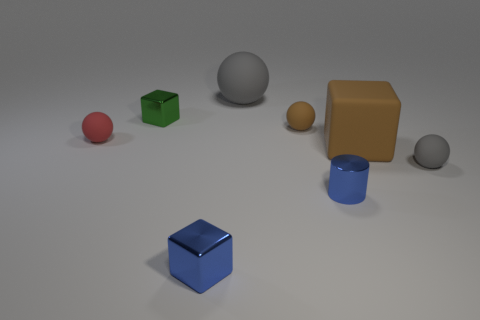There is a small thing that is the same color as the small shiny cylinder; what shape is it?
Make the answer very short. Cube. How many tiny metallic blocks are the same color as the tiny cylinder?
Your answer should be very brief. 1. Do the small sphere that is behind the tiny red matte sphere and the matte block have the same color?
Your response must be concise. Yes. What number of gray things are made of the same material as the large brown object?
Provide a short and direct response. 2. There is a gray ball behind the metallic block behind the ball to the left of the small green thing; what size is it?
Make the answer very short. Large. There is a small red thing; how many small green metal cubes are right of it?
Make the answer very short. 1. Is the number of large gray objects greater than the number of matte spheres?
Ensure brevity in your answer.  No. There is a object that is both behind the red rubber thing and to the left of the big gray matte sphere; what size is it?
Your answer should be very brief. Small. There is a blue thing that is on the left side of the blue object that is right of the gray thing that is on the left side of the tiny gray object; what is its material?
Keep it short and to the point. Metal. There is another ball that is the same color as the large sphere; what material is it?
Your response must be concise. Rubber. 